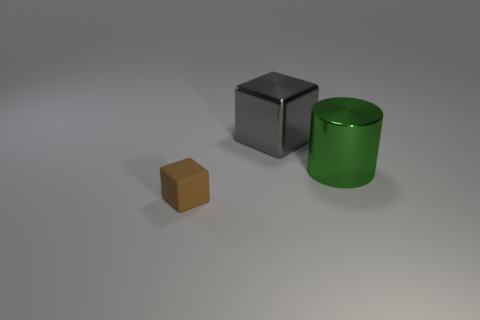How many objects are either green metallic cylinders or blocks on the right side of the tiny rubber thing?
Your response must be concise. 2. The metallic block has what color?
Keep it short and to the point. Gray. There is a object behind the big cylinder; what color is it?
Give a very brief answer. Gray. There is a shiny thing to the right of the metallic block; how many big gray metallic objects are right of it?
Provide a succinct answer. 0. Do the brown matte cube and the shiny thing to the right of the large gray metallic object have the same size?
Ensure brevity in your answer.  No. Are there any gray things of the same size as the shiny cylinder?
Your answer should be compact. Yes. What number of things are either large blue cylinders or big things?
Give a very brief answer. 2. There is a block to the left of the metal cube; does it have the same size as the cube that is behind the big green cylinder?
Ensure brevity in your answer.  No. Are there any tiny red rubber things of the same shape as the small brown matte object?
Your response must be concise. No. Are there fewer tiny cubes that are behind the green metal cylinder than large cylinders?
Your response must be concise. Yes. 